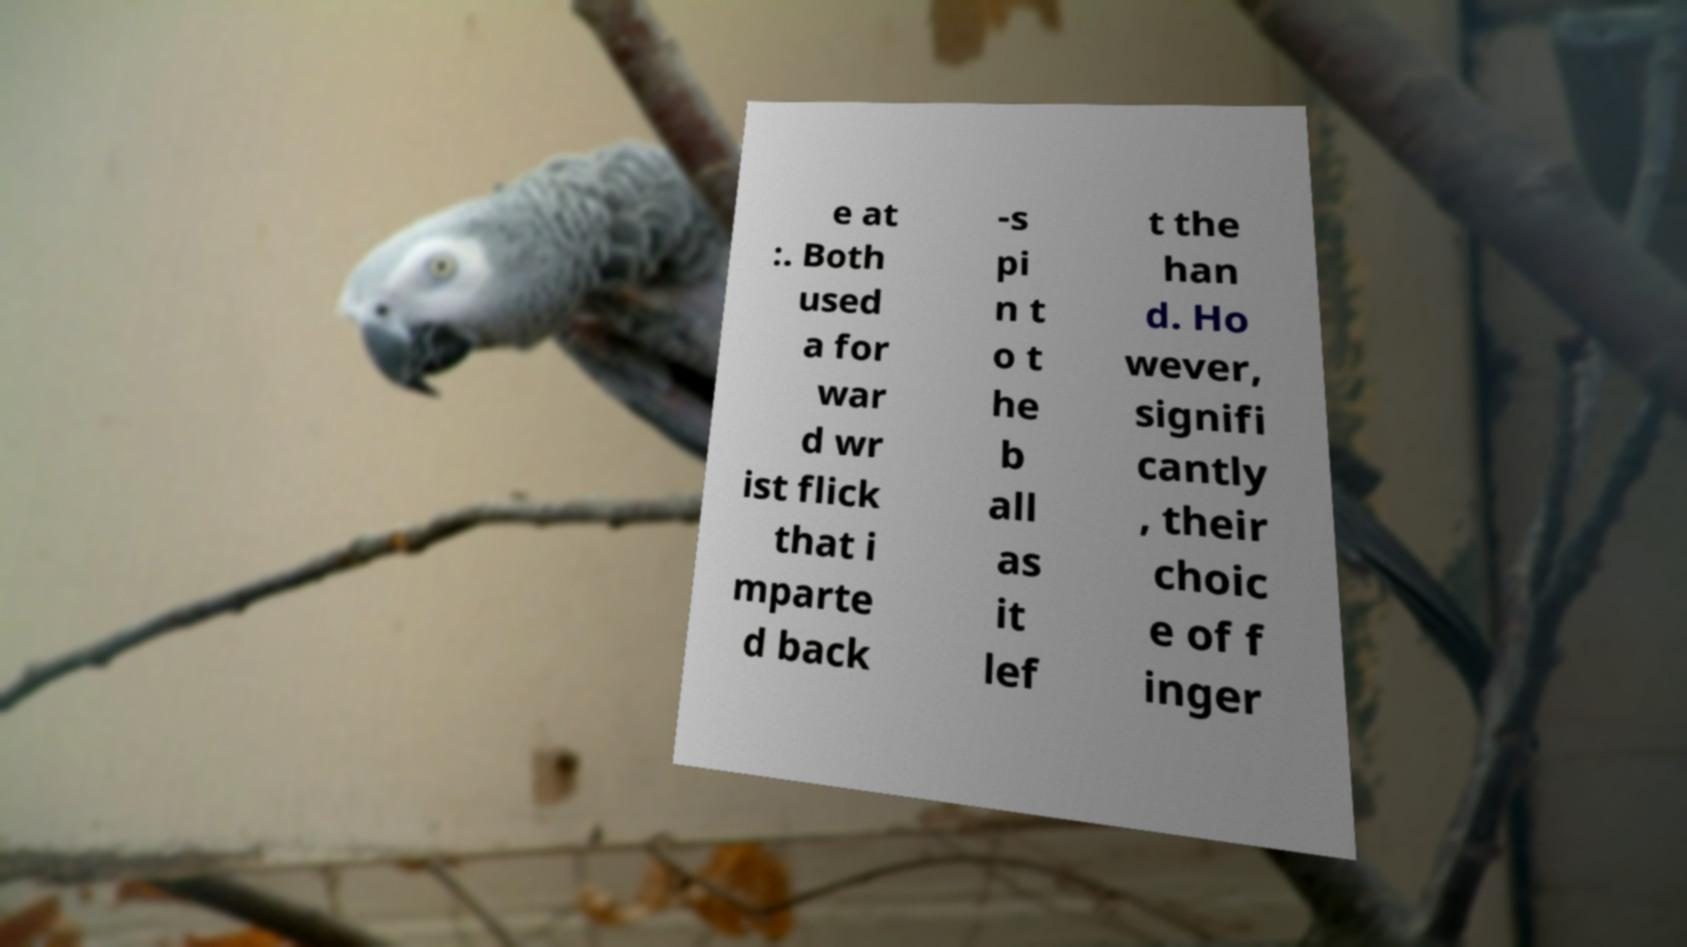There's text embedded in this image that I need extracted. Can you transcribe it verbatim? e at :. Both used a for war d wr ist flick that i mparte d back -s pi n t o t he b all as it lef t the han d. Ho wever, signifi cantly , their choic e of f inger 